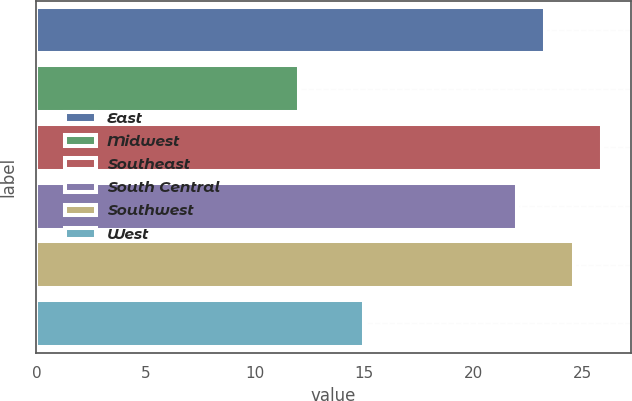<chart> <loc_0><loc_0><loc_500><loc_500><bar_chart><fcel>East<fcel>Midwest<fcel>Southeast<fcel>South Central<fcel>Southwest<fcel>West<nl><fcel>23.3<fcel>12<fcel>25.9<fcel>22<fcel>24.6<fcel>15<nl></chart> 